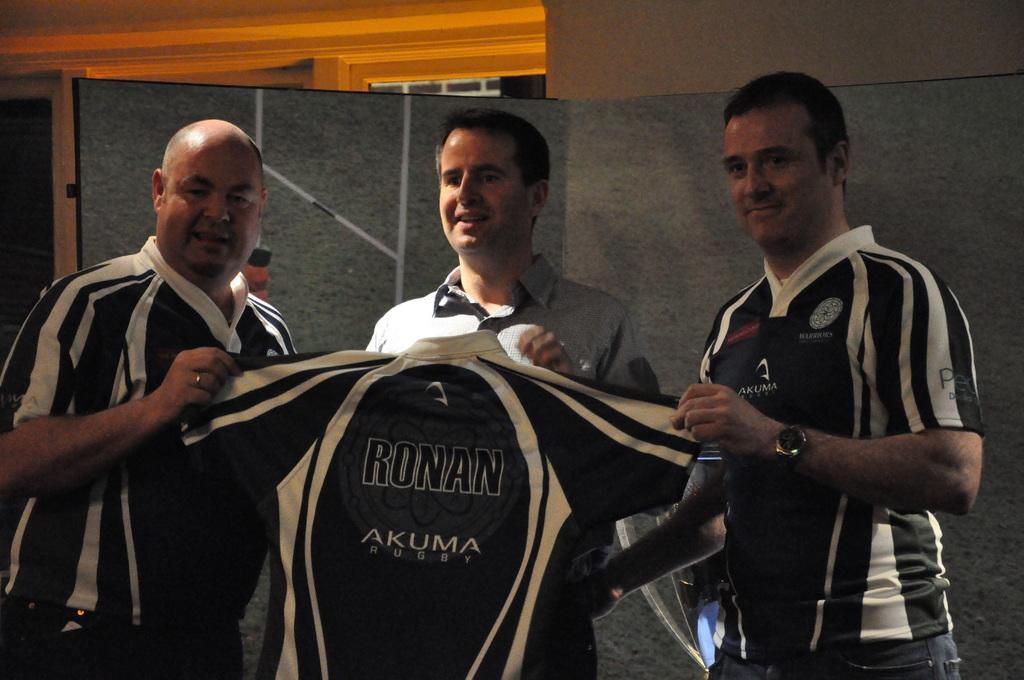<image>
Provide a brief description of the given image. Three men display a blue and white jersey with the name Ronan on it. 